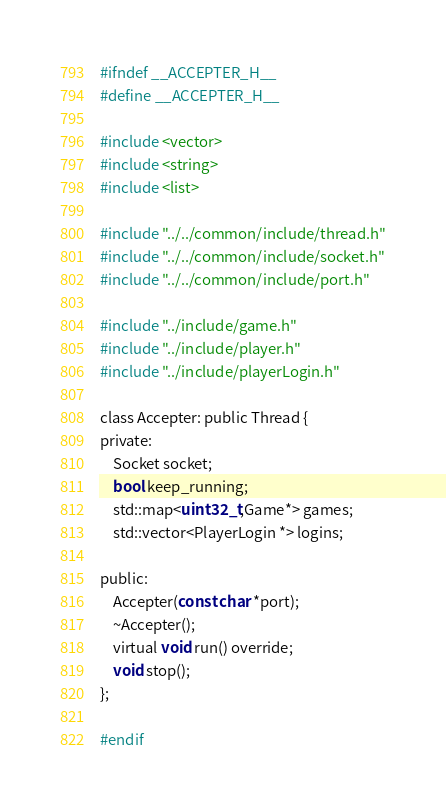Convert code to text. <code><loc_0><loc_0><loc_500><loc_500><_C_>#ifndef __ACCEPTER_H__
#define __ACCEPTER_H__

#include <vector>
#include <string>
#include <list>

#include "../../common/include/thread.h"
#include "../../common/include/socket.h"
#include "../../common/include/port.h"

#include "../include/game.h"
#include "../include/player.h"
#include "../include/playerLogin.h"

class Accepter: public Thread {
private:
    Socket socket;
    bool keep_running;
    std::map<uint32_t,Game*> games;
    std::vector<PlayerLogin *> logins;
    
public:
    Accepter(const char *port);
    ~Accepter();
    virtual void run() override;
    void stop();
};

#endif
</code> 